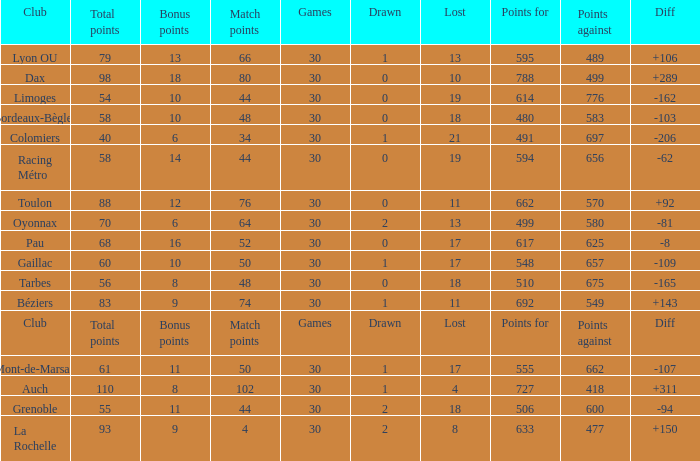How many bonus points did the Colomiers earn? 6.0. 